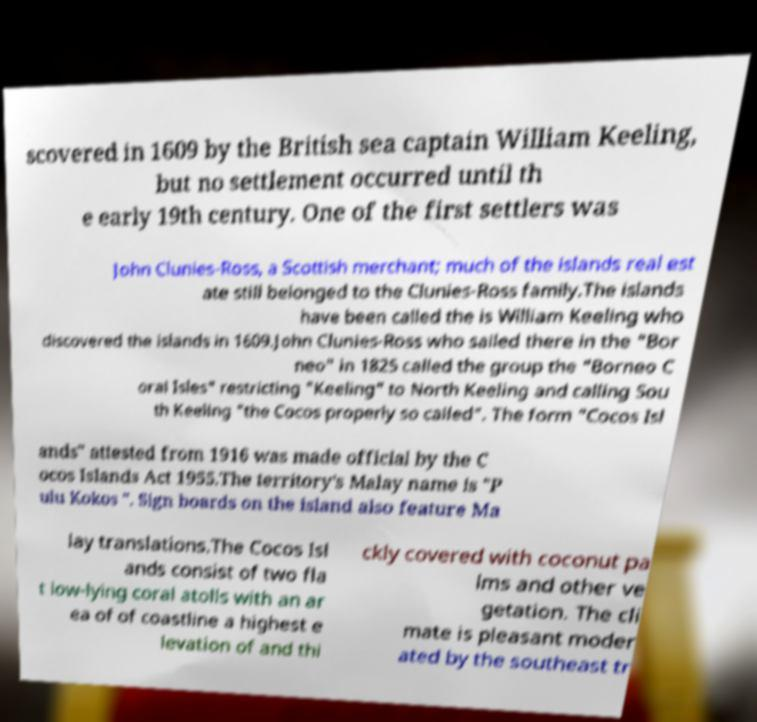There's text embedded in this image that I need extracted. Can you transcribe it verbatim? scovered in 1609 by the British sea captain William Keeling, but no settlement occurred until th e early 19th century. One of the first settlers was John Clunies-Ross, a Scottish merchant; much of the islands real est ate still belonged to the Clunies-Ross family.The islands have been called the is William Keeling who discovered the islands in 1609.John Clunies-Ross who sailed there in the "Bor neo" in 1825 called the group the "Borneo C oral Isles" restricting "Keeling" to North Keeling and calling Sou th Keeling "the Cocos properly so called". The form "Cocos Isl ands" attested from 1916 was made official by the C ocos Islands Act 1955.The territory's Malay name is "P ulu Kokos ". Sign boards on the island also feature Ma lay translations.The Cocos Isl ands consist of two fla t low-lying coral atolls with an ar ea of of coastline a highest e levation of and thi ckly covered with coconut pa lms and other ve getation. The cli mate is pleasant moder ated by the southeast tr 